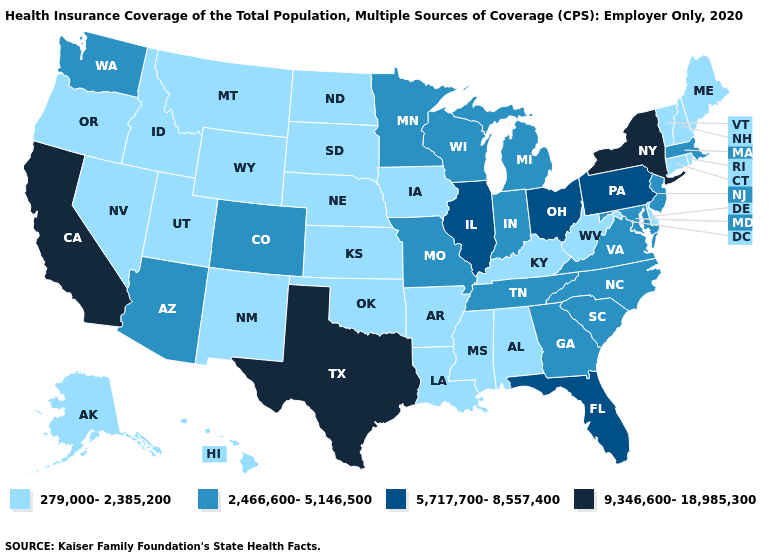What is the highest value in the West ?
Write a very short answer. 9,346,600-18,985,300. What is the value of Wisconsin?
Answer briefly. 2,466,600-5,146,500. What is the highest value in the USA?
Concise answer only. 9,346,600-18,985,300. Among the states that border Colorado , which have the lowest value?
Answer briefly. Kansas, Nebraska, New Mexico, Oklahoma, Utah, Wyoming. Does Georgia have a lower value than Alabama?
Concise answer only. No. What is the value of North Dakota?
Concise answer only. 279,000-2,385,200. Does Pennsylvania have the highest value in the Northeast?
Keep it brief. No. What is the value of Maine?
Be succinct. 279,000-2,385,200. Does California have a higher value than Texas?
Short answer required. No. How many symbols are there in the legend?
Short answer required. 4. Does the map have missing data?
Be succinct. No. Name the states that have a value in the range 9,346,600-18,985,300?
Concise answer only. California, New York, Texas. Does California have the highest value in the USA?
Concise answer only. Yes. Name the states that have a value in the range 279,000-2,385,200?
Quick response, please. Alabama, Alaska, Arkansas, Connecticut, Delaware, Hawaii, Idaho, Iowa, Kansas, Kentucky, Louisiana, Maine, Mississippi, Montana, Nebraska, Nevada, New Hampshire, New Mexico, North Dakota, Oklahoma, Oregon, Rhode Island, South Dakota, Utah, Vermont, West Virginia, Wyoming. Name the states that have a value in the range 9,346,600-18,985,300?
Keep it brief. California, New York, Texas. 